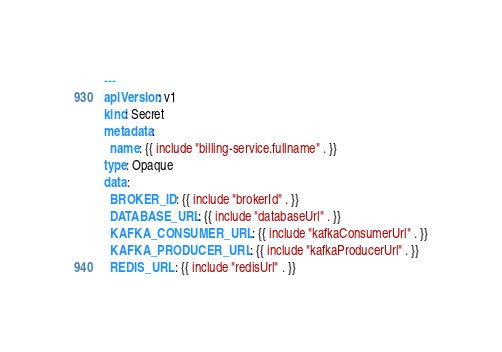Convert code to text. <code><loc_0><loc_0><loc_500><loc_500><_YAML_>---
apiVersion: v1
kind: Secret
metadata:
  name: {{ include "billing-service.fullname" . }}
type: Opaque
data:
  BROKER_ID: {{ include "brokerId" . }}
  DATABASE_URL: {{ include "databaseUrl" . }}
  KAFKA_CONSUMER_URL: {{ include "kafkaConsumerUrl" . }}
  KAFKA_PRODUCER_URL: {{ include "kafkaProducerUrl" . }}
  REDIS_URL: {{ include "redisUrl" . }}
</code> 